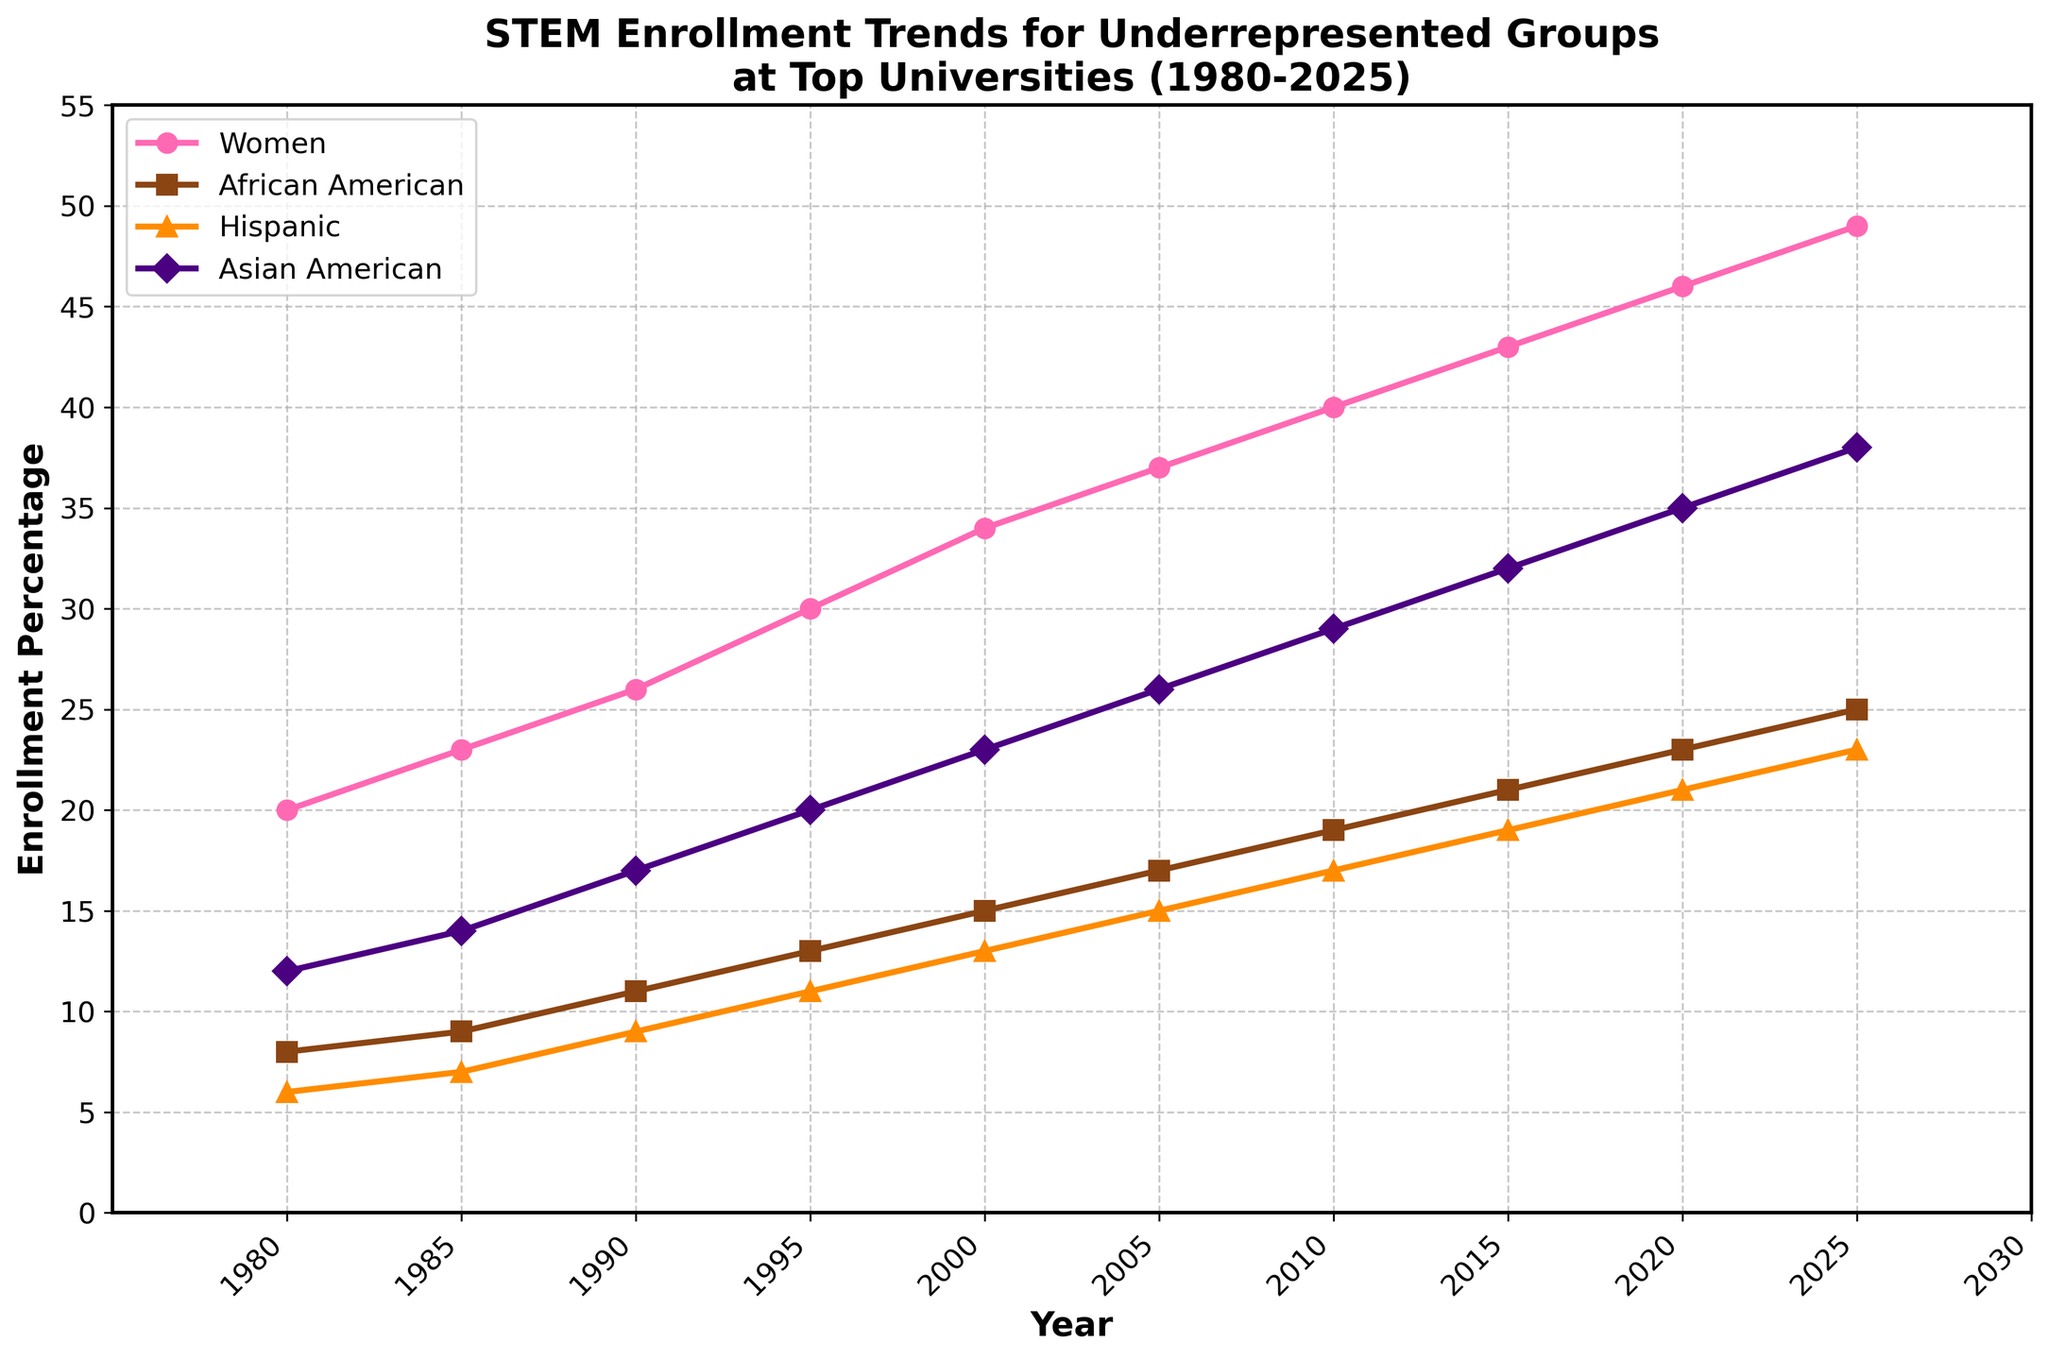what is the trend for women’s enrollment over the years? The trend for women’s enrollment consistently increases from 20% in 1980 to 49% in 2025.
Answer: Increasing Compare the enrollment percentages of Hispanic and Asian American groups in 2000. Which group has a higher percentage? In 2000, the enrollment percentage for Hispanics is 13% while for Asian Americans it is 23%.
Answer: Asian American Which group had the lowest enrollment percentage in 2010? In 2010, the enrollments are 40% for women, 19% for African American, 17% for Hispanic, and 29% for Asian American. The lowest is Hispanic with 17%.
Answer: Hispanic What is the average enrollment percentage for African Americans across all years? The enrollment percentages for African Americans are 8, 9, 11, 13, 15, 17, 19, 21, 23, and 25. The sum is 161. There are 10 years, so the average is 161/10 = 16.1.
Answer: 16.1 How many years does it take for Hispanic enrollment to exceed 20%? Hispanic enrollment exceeds 20% in 2020. It started at 6% in 1980, taking 40 years to exceed 20%.
Answer: 40 years Which minority group saw the most significant increase in enrollment percentage between 1980 and 2025? Comparing the increases: African American (25-8=17), Hispanic (23-6=17), and Asian American (38-12=26). The most significant increase is for Asian Americans.
Answer: Asian American What can be inferred from the visualization regarding the intersectionality of women and minorities’ representation in STEM fields over time? The visualization shows that both women and minority groups' representation in STEM fields is increasing over time, indicating growing inclusivity and diversity.
Answer: Growing inclusivity and diversity In which decade did Asian Americans see the highest increase in enrollment percentage? Comparing each decade: 1980-1990 (17-12=5), 1990-2000 (23-17=6), 2000-2010 (29-23=6), 2010-2020 (35-29=6). The highest increase of 6% happened across multiple decades (1990-2000, 2000-2010, and 2010-2020).
Answer: 1990-2000, 2000-2010, and 2010-2020 What is the difference between the enrollment percentages of women and African Americans in 2025? In 2025, the enrollment for women is 49% while for African Americans it is 25%, resulting in a difference of 24%.
Answer: 24% 